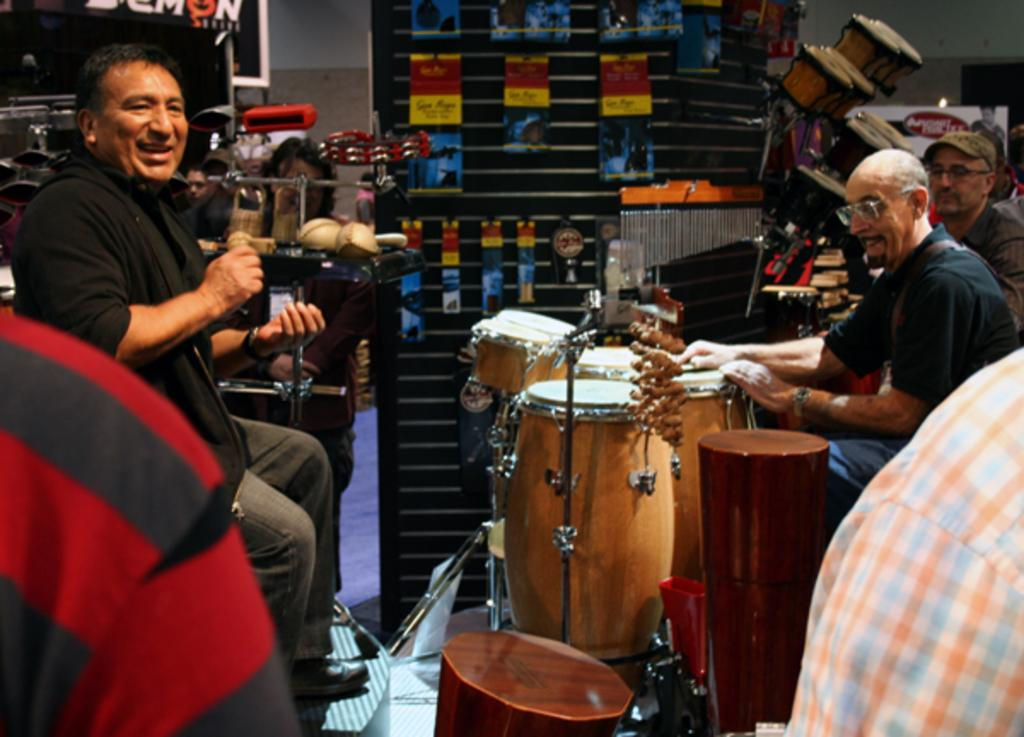Who or what is present in the image? There are people in the image. What are the people doing in the image? The people are sitting on chairs and playing musical instruments. What type of cup can be seen in the hands of the people playing musical instruments? There is no cup present in the image; the people are playing musical instruments with their hands. 